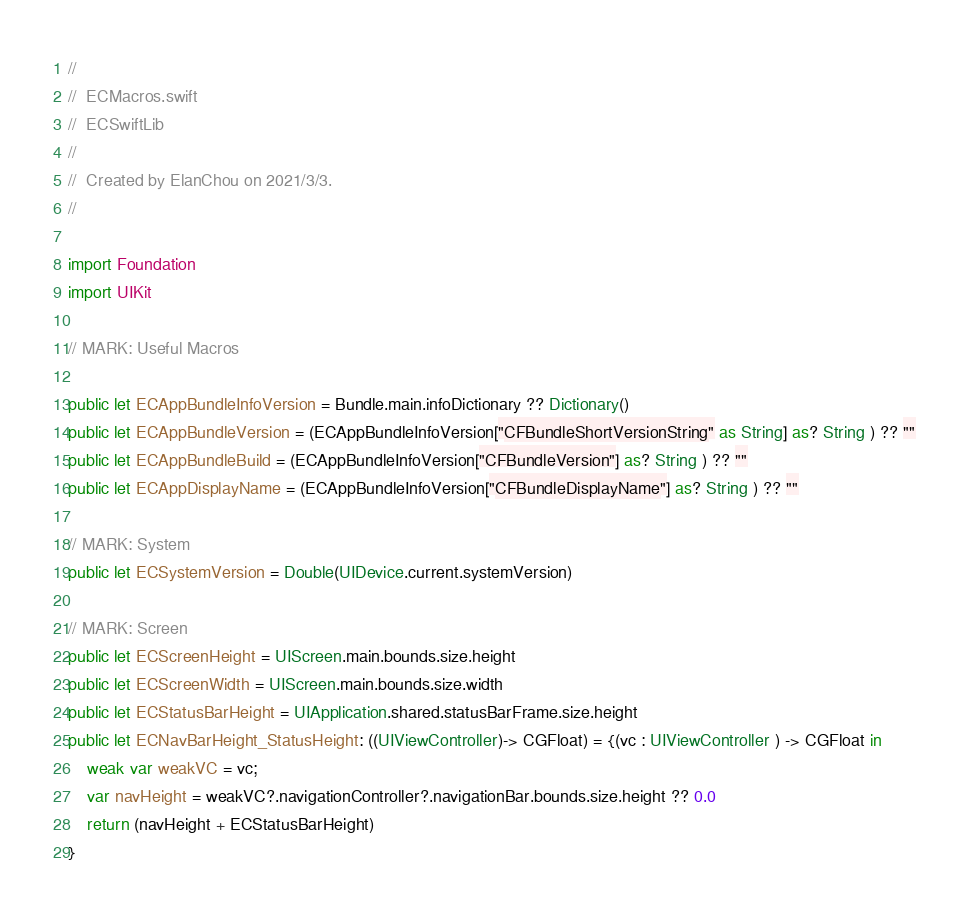<code> <loc_0><loc_0><loc_500><loc_500><_Swift_>//
//  ECMacros.swift
//  ECSwiftLib
//
//  Created by ElanChou on 2021/3/3.
//

import Foundation
import UIKit

// MARK: Useful Macros

public let ECAppBundleInfoVersion = Bundle.main.infoDictionary ?? Dictionary()
public let ECAppBundleVersion = (ECAppBundleInfoVersion["CFBundleShortVersionString" as String] as? String ) ?? ""
public let ECAppBundleBuild = (ECAppBundleInfoVersion["CFBundleVersion"] as? String ) ?? ""
public let ECAppDisplayName = (ECAppBundleInfoVersion["CFBundleDisplayName"] as? String ) ?? ""

// MARK: System
public let ECSystemVersion = Double(UIDevice.current.systemVersion)

// MARK: Screen
public let ECScreenHeight = UIScreen.main.bounds.size.height
public let ECScreenWidth = UIScreen.main.bounds.size.width
public let ECStatusBarHeight = UIApplication.shared.statusBarFrame.size.height
public let ECNavBarHeight_StatusHeight: ((UIViewController)-> CGFloat) = {(vc : UIViewController ) -> CGFloat in
    weak var weakVC = vc;
    var navHeight = weakVC?.navigationController?.navigationBar.bounds.size.height ?? 0.0
    return (navHeight + ECStatusBarHeight)
}
</code> 